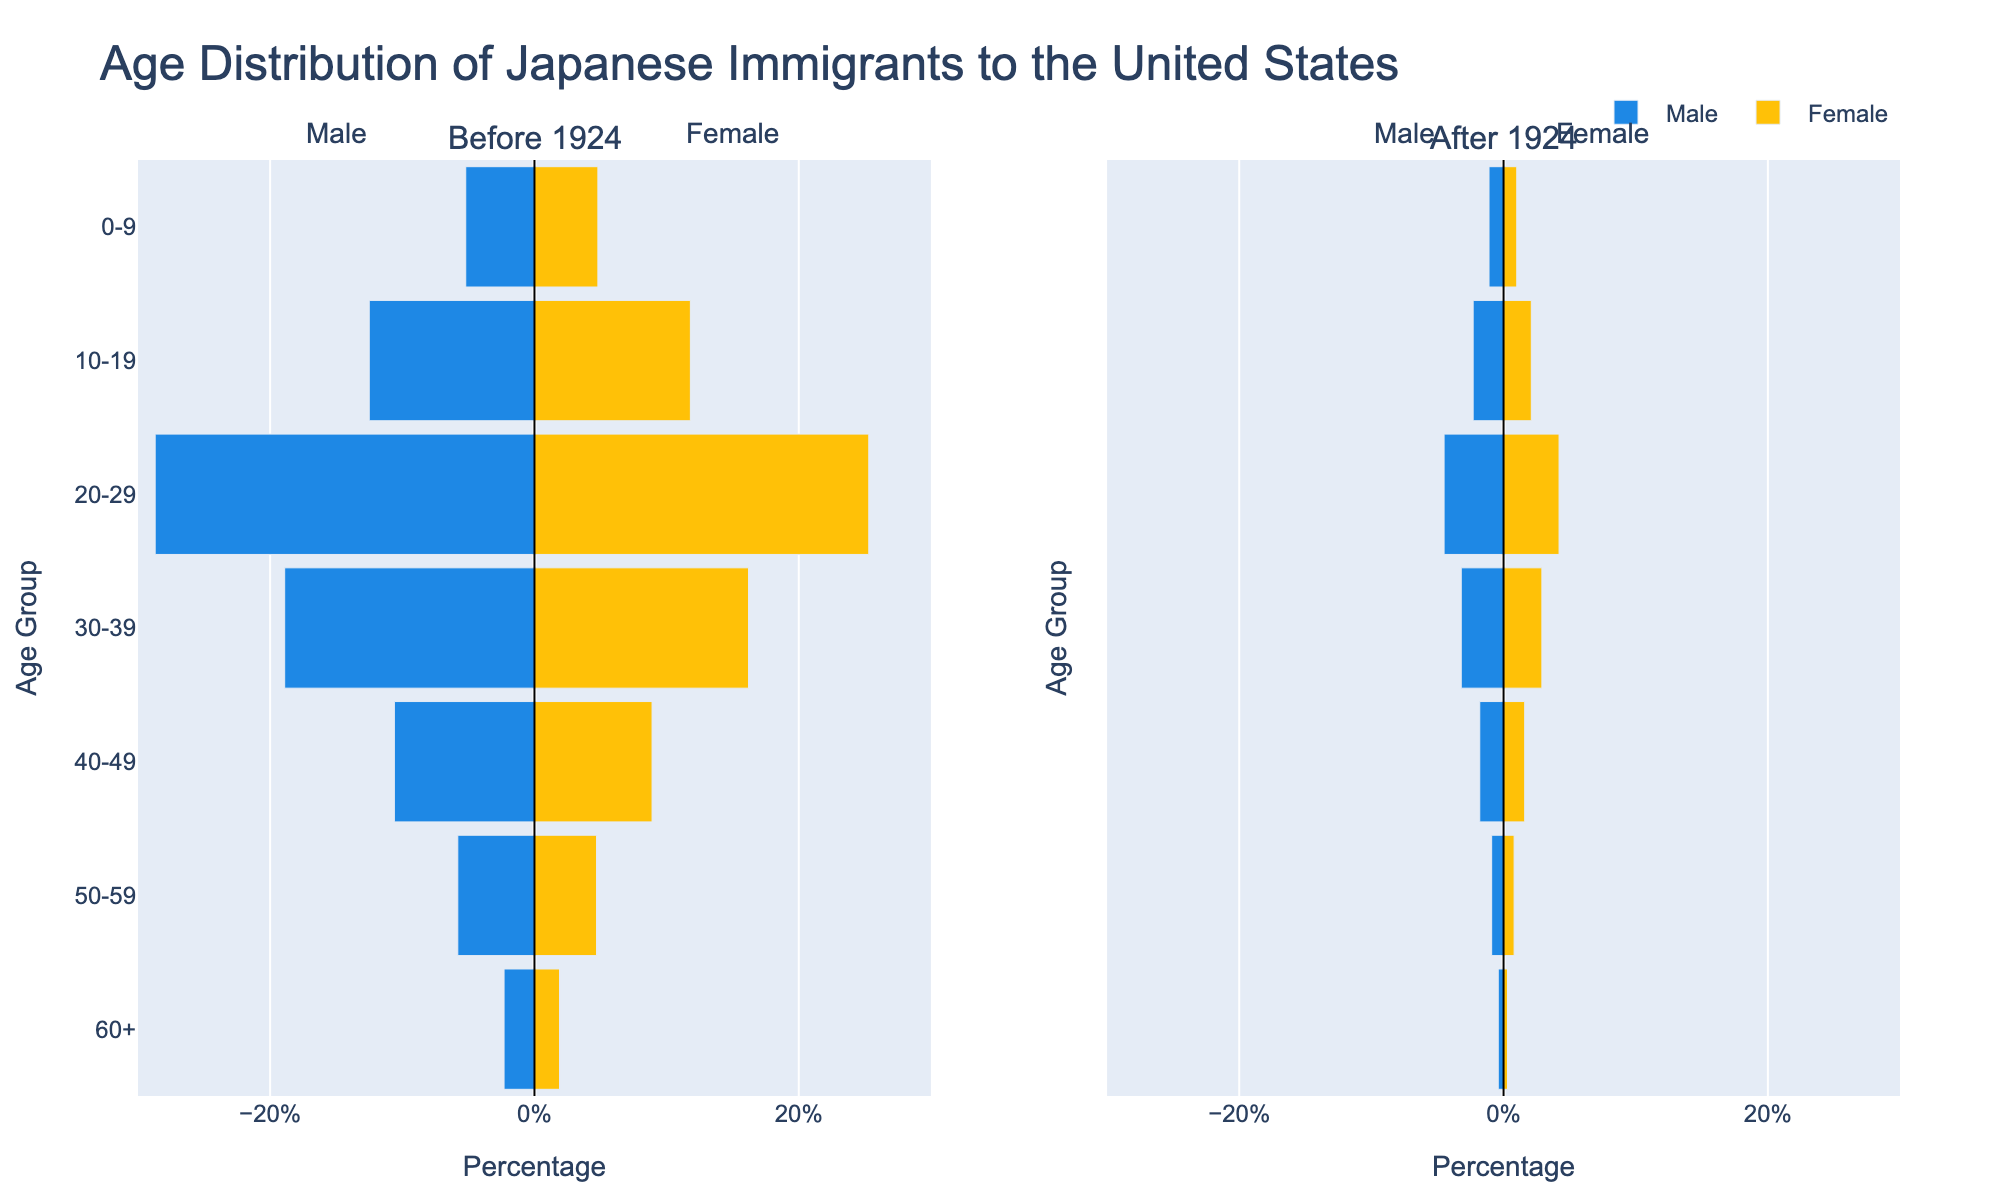What's the title of the chart? The title is displayed at the top center of the chart and reads "Age Distribution of Japanese Immigrants to the United States".
Answer: Age Distribution of Japanese Immigrants to the United States What do the blue bars represent in the chart? The blue bars are labeled as "Male" in the legend and the annotations. They represent the percentage of male Japanese immigrants in each age group.
Answer: Male Japanese immigrants How does the population of Japanese male immigrants aged 20-29 before 1924 compare to after 1924? By comparing the lengths of blue bars in the 20-29 age group, it's clear that the percentage of male immigrants aged 20-29 before 1924 (28.7%) is much higher than after 1924 (4.5%).
Answer: Higher before 1924 What is the percentage of female Japanese immigrants aged 30-39 after 1924? The yellow bar corresponding to the female Japanese immigrants aged 30-39 after 1924 marks at 2.9%.
Answer: 2.9% In which age group did the percentage of female Japanese immigrants both before and after 1924 increase? By comparing the lengths of yellow bars for each age group, we see that there is no age group where the percentage of female Japanese immigrants increased after 1924 compared to before 1924.
Answer: None What's the total percentage of Japanese male immigrants aged 50-59 and 60+ after 1924? The total is found by adding the lengths of the blue bars for the 50-59 (0.9%) and 60+ (0.4%) age groups after 1924, which is 0.9% + 0.4% = 1.3%.
Answer: 1.3% How does the gender distribution of Japanese immigrants change after the Immigration Act of 1924 in the 0-9 age group? The percentage of male Japanese immigrants in the 0-9 age group changed from 5.2% before 1924 to 1.1% after 1924, while the percentage of female immigrants changed from 4.8% to 1.0%. Both percentages decreased.
Answer: Both decreased Compare the decrease in percentage of male Japanese immigrants aged 40-49 to those aged 20-29 after 1924. The decrease for males aged 40-49 is from 10.6% to 1.8%, a decrease of 8.8%. For those aged 20-29, the decrease is from 28.7% to 4.5%, a decrease of 24.2%. The decrease is larger for the 20-29 age group.
Answer: Larger for 20-29 age group What age group had the smallest percentage of Japanese female immigrants before 1924? By examining the yellow bars before 1924, the smallest percentage corresponds to the 60+ age group, standing at 1.9%.
Answer: 60+ age group Calculate the difference in percentage of Japanese female immigrants in the 10-19 age group before and after 1924. The percentage of female immigrants aged 10-19 before 1924 is 11.8%, and after 1924 it is 2.1%. The difference is 11.8% - 2.1% = 9.7%.
Answer: 9.7% 